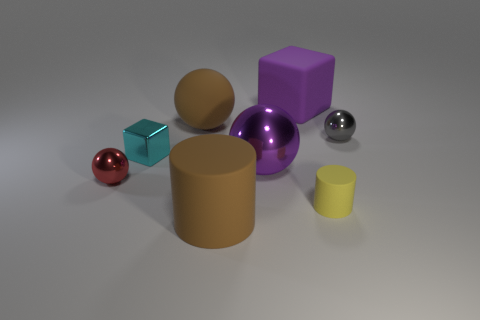Add 2 large purple blocks. How many objects exist? 10 Subtract all blue balls. Subtract all cyan cylinders. How many balls are left? 4 Subtract all cubes. How many objects are left? 6 Subtract all big cyan blocks. Subtract all tiny red things. How many objects are left? 7 Add 7 tiny gray balls. How many tiny gray balls are left? 8 Add 8 big metallic balls. How many big metallic balls exist? 9 Subtract 1 gray spheres. How many objects are left? 7 